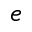<formula> <loc_0><loc_0><loc_500><loc_500>e</formula> 